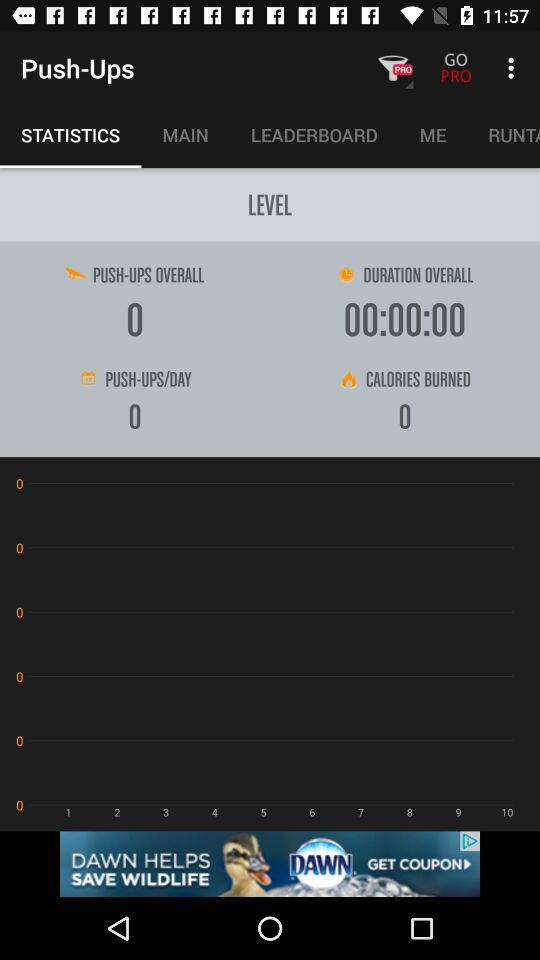How many calories are burned? There are 0 calories burned. 